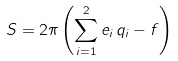<formula> <loc_0><loc_0><loc_500><loc_500>S = 2 \pi \left ( \sum _ { i = 1 } ^ { 2 } e _ { i } \, q _ { i } - f \right )</formula> 